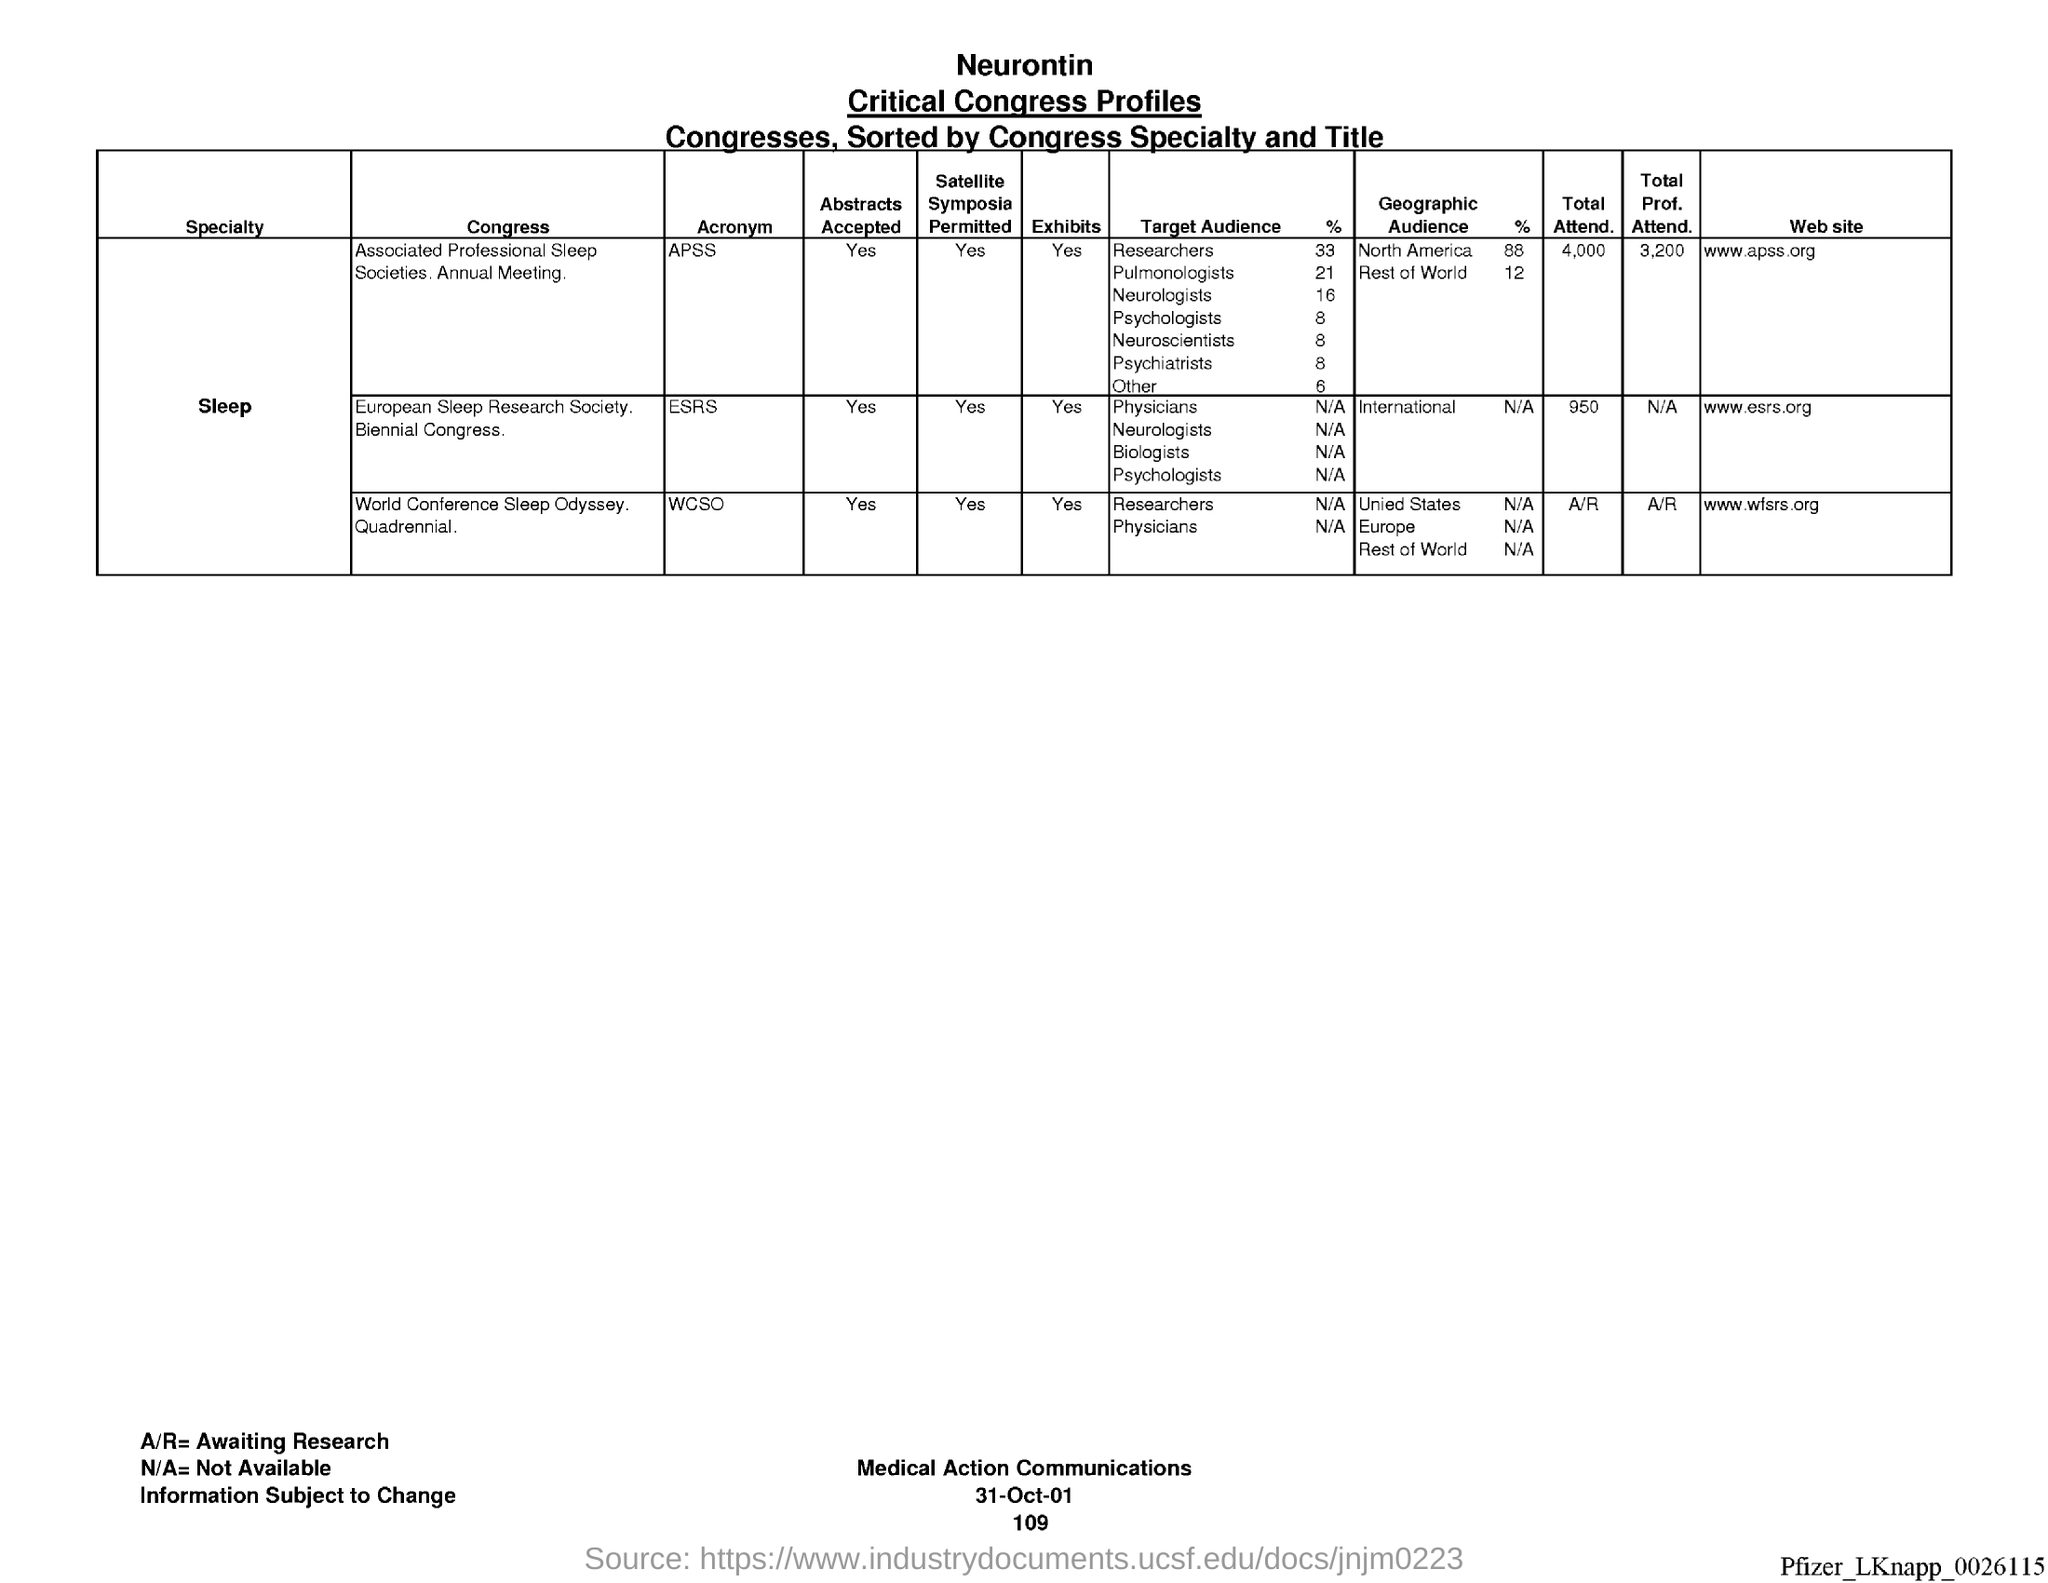What is the Title of the Table?
Provide a short and direct response. Critical Congress Profiles. What is the Total Attend. for APSS?
Give a very brief answer. 4,000. What is the Total Attend. for ESRS?
Provide a short and direct response. 950. What is the Total Prof. Attend. for APSS?
Make the answer very short. 3,200. What is the Total Prof. Attend. for ESRS?
Keep it short and to the point. N/A. What is the Website for APSS?
Your answer should be compact. Www.apss.org. What is the Website for ESRS?
Offer a terse response. Www.esrs.org. 